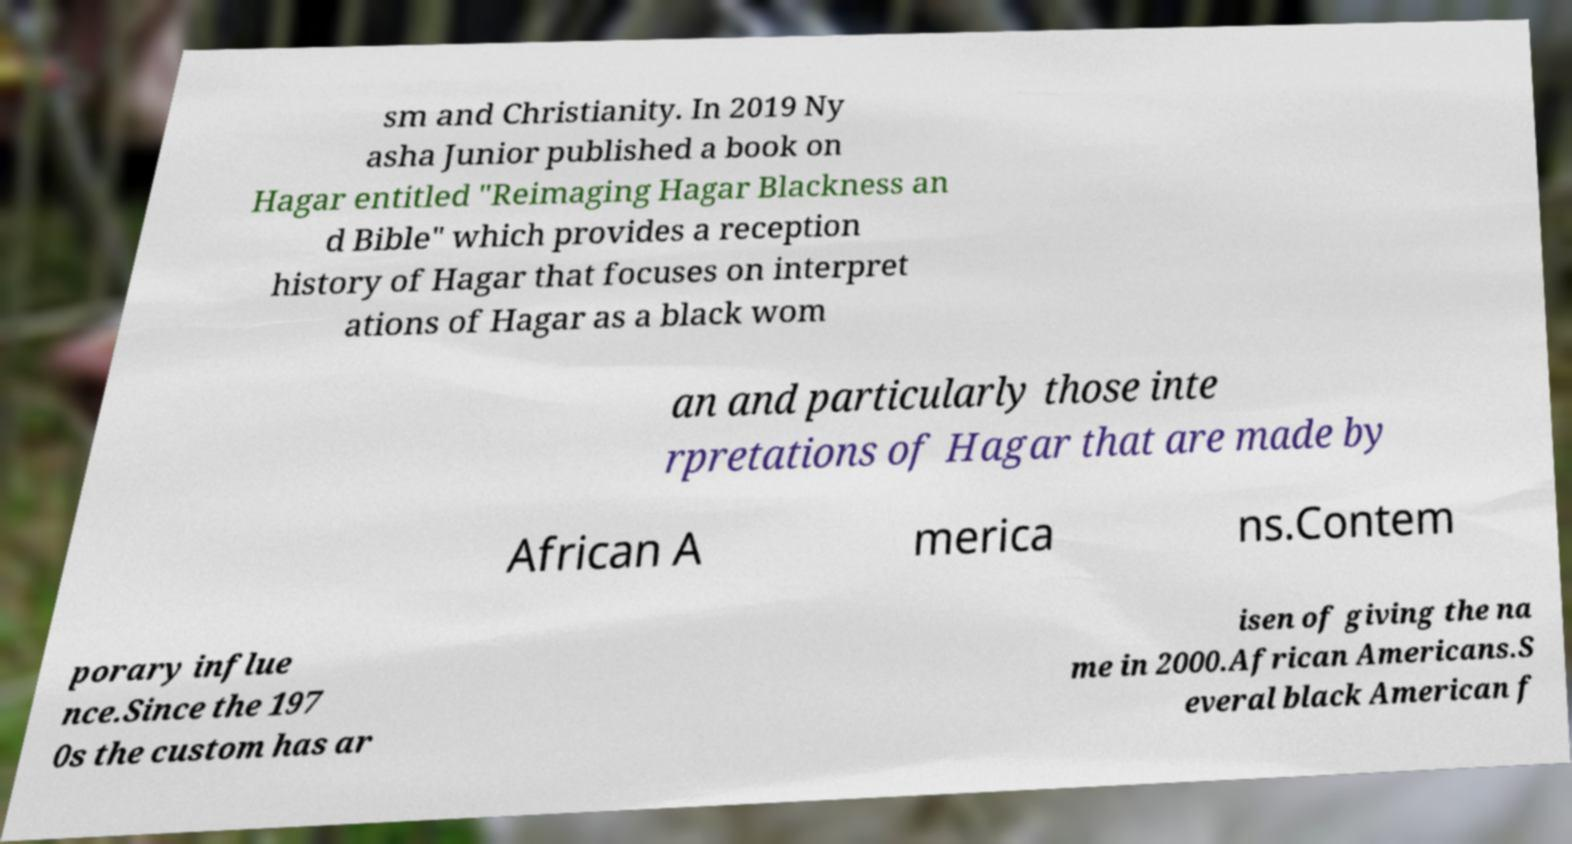For documentation purposes, I need the text within this image transcribed. Could you provide that? sm and Christianity. In 2019 Ny asha Junior published a book on Hagar entitled "Reimaging Hagar Blackness an d Bible" which provides a reception history of Hagar that focuses on interpret ations of Hagar as a black wom an and particularly those inte rpretations of Hagar that are made by African A merica ns.Contem porary influe nce.Since the 197 0s the custom has ar isen of giving the na me in 2000.African Americans.S everal black American f 